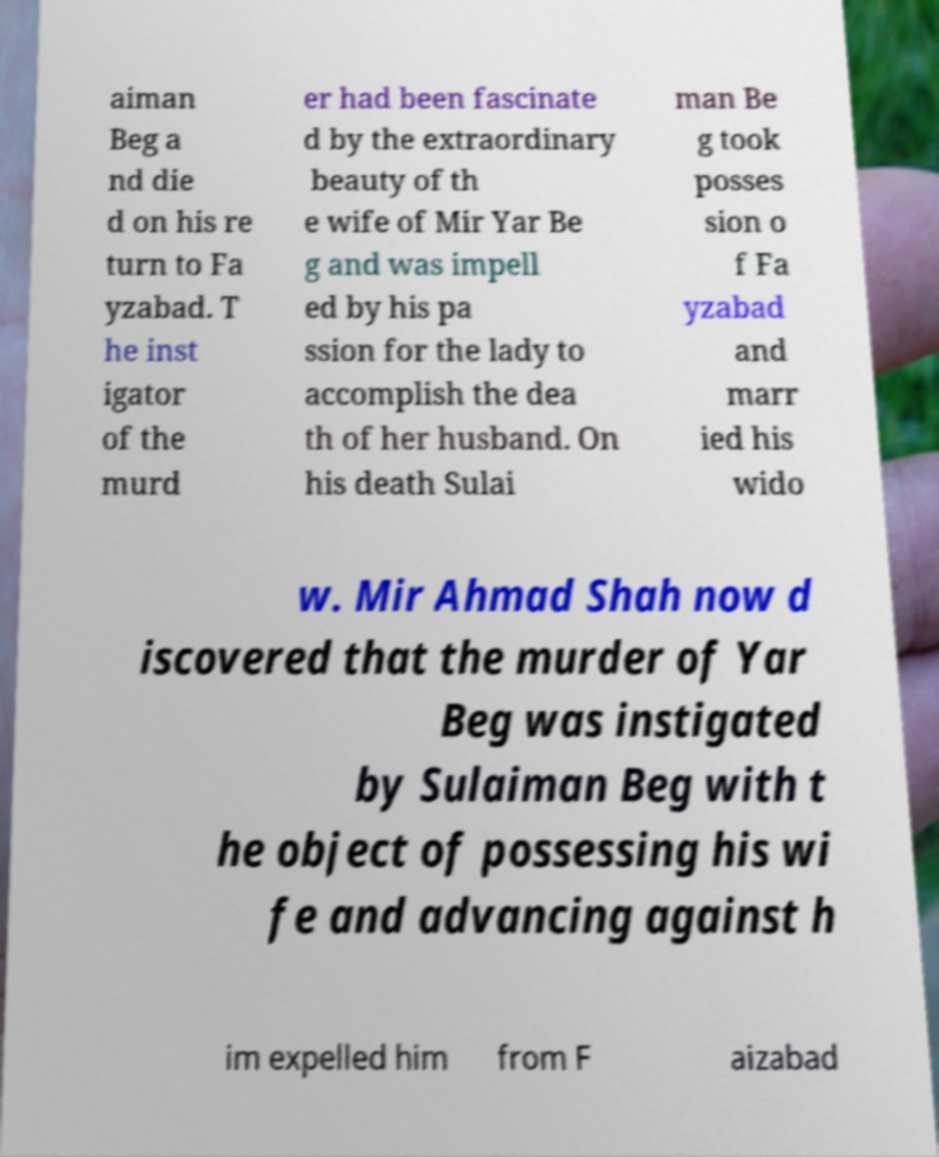Can you accurately transcribe the text from the provided image for me? aiman Beg a nd die d on his re turn to Fa yzabad. T he inst igator of the murd er had been fascinate d by the extraordinary beauty of th e wife of Mir Yar Be g and was impell ed by his pa ssion for the lady to accomplish the dea th of her husband. On his death Sulai man Be g took posses sion o f Fa yzabad and marr ied his wido w. Mir Ahmad Shah now d iscovered that the murder of Yar Beg was instigated by Sulaiman Beg with t he object of possessing his wi fe and advancing against h im expelled him from F aizabad 